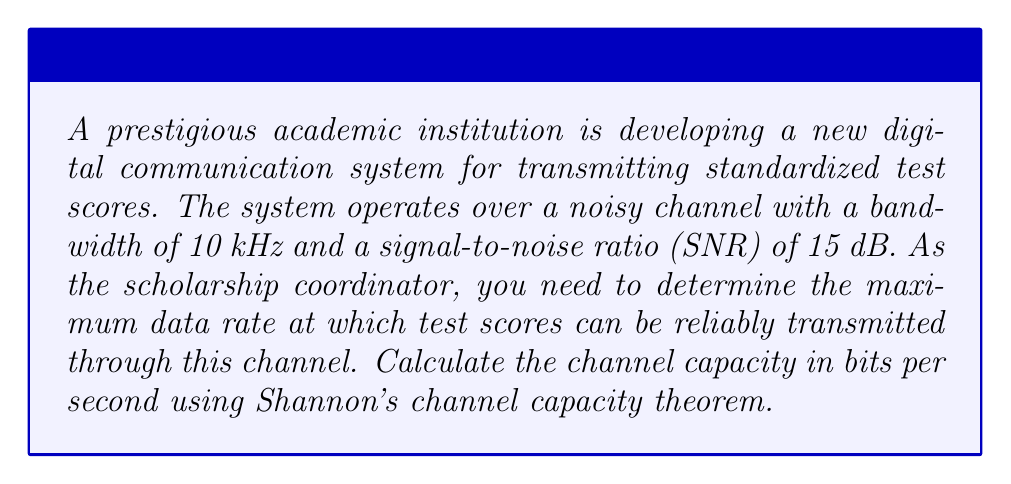Provide a solution to this math problem. To solve this problem, we'll use Shannon's channel capacity theorem, which is fundamental in information theory. The theorem states that the channel capacity $C$ for a noisy channel is given by:

$$C = B \log_2(1 + SNR)$$

Where:
$C$ is the channel capacity in bits per second (bps)
$B$ is the bandwidth in Hz
$SNR$ is the signal-to-noise ratio

Given:
- Bandwidth $B = 10$ kHz $= 10,000$ Hz
- SNR $= 15$ dB

Step 1: Convert SNR from dB to linear scale
SNR in linear scale $= 10^{(SNR_{dB}/10)} = 10^{(15/10)} = 10^{1.5} \approx 31.6228$

Step 2: Apply Shannon's channel capacity theorem
$$\begin{align}
C &= B \log_2(1 + SNR) \\
&= 10,000 \log_2(1 + 31.6228) \\
&= 10,000 \log_2(32.6228)
\end{align}$$

Step 3: Calculate the logarithm
$\log_2(32.6228) \approx 5.0279$

Step 4: Multiply by the bandwidth
$$C = 10,000 \times 5.0279 \approx 50,279 \text{ bps}$$

Therefore, the channel capacity is approximately 50,279 bits per second.
Answer: The channel capacity is approximately 50,279 bits per second. 